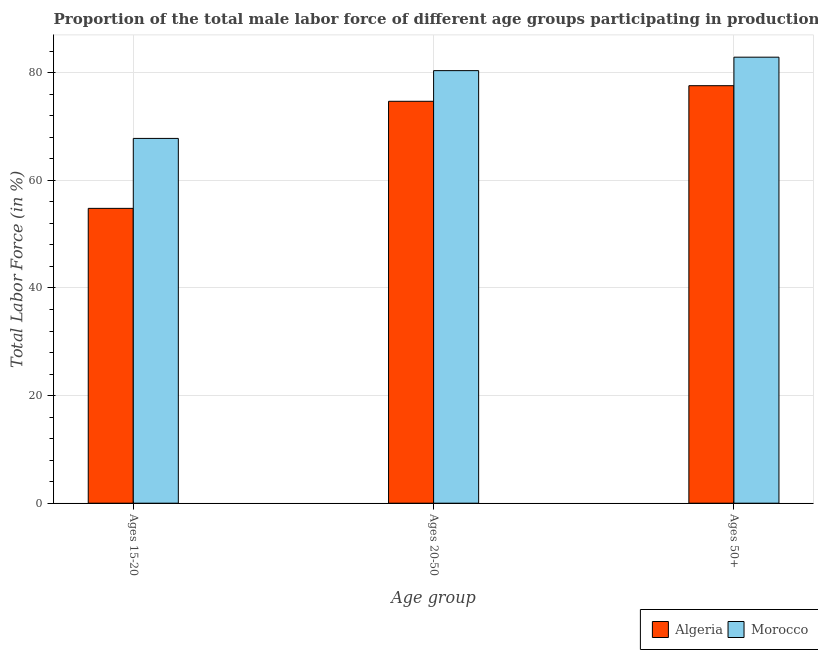How many different coloured bars are there?
Your answer should be very brief. 2. How many bars are there on the 2nd tick from the right?
Ensure brevity in your answer.  2. What is the label of the 2nd group of bars from the left?
Provide a succinct answer. Ages 20-50. What is the percentage of male labor force within the age group 15-20 in Algeria?
Ensure brevity in your answer.  54.8. Across all countries, what is the maximum percentage of male labor force above age 50?
Offer a terse response. 82.9. Across all countries, what is the minimum percentage of male labor force within the age group 20-50?
Make the answer very short. 74.7. In which country was the percentage of male labor force within the age group 20-50 maximum?
Your response must be concise. Morocco. In which country was the percentage of male labor force above age 50 minimum?
Your answer should be very brief. Algeria. What is the total percentage of male labor force above age 50 in the graph?
Make the answer very short. 160.5. What is the difference between the percentage of male labor force within the age group 15-20 in Morocco and that in Algeria?
Provide a succinct answer. 13. What is the difference between the percentage of male labor force within the age group 15-20 in Algeria and the percentage of male labor force above age 50 in Morocco?
Your response must be concise. -28.1. What is the average percentage of male labor force above age 50 per country?
Ensure brevity in your answer.  80.25. What is the difference between the percentage of male labor force within the age group 20-50 and percentage of male labor force above age 50 in Algeria?
Provide a succinct answer. -2.9. In how many countries, is the percentage of male labor force above age 50 greater than 76 %?
Offer a terse response. 2. What is the ratio of the percentage of male labor force above age 50 in Algeria to that in Morocco?
Offer a very short reply. 0.94. Is the difference between the percentage of male labor force within the age group 15-20 in Algeria and Morocco greater than the difference between the percentage of male labor force above age 50 in Algeria and Morocco?
Offer a very short reply. No. What is the difference between the highest and the second highest percentage of male labor force within the age group 20-50?
Your answer should be very brief. 5.7. What is the difference between the highest and the lowest percentage of male labor force within the age group 20-50?
Provide a short and direct response. 5.7. In how many countries, is the percentage of male labor force within the age group 20-50 greater than the average percentage of male labor force within the age group 20-50 taken over all countries?
Give a very brief answer. 1. Is the sum of the percentage of male labor force within the age group 20-50 in Morocco and Algeria greater than the maximum percentage of male labor force within the age group 15-20 across all countries?
Your answer should be compact. Yes. What does the 1st bar from the left in Ages 50+ represents?
Ensure brevity in your answer.  Algeria. What does the 1st bar from the right in Ages 20-50 represents?
Your answer should be compact. Morocco. How many countries are there in the graph?
Keep it short and to the point. 2. What is the difference between two consecutive major ticks on the Y-axis?
Your response must be concise. 20. How are the legend labels stacked?
Your answer should be compact. Horizontal. What is the title of the graph?
Your answer should be compact. Proportion of the total male labor force of different age groups participating in production in 1990. What is the label or title of the X-axis?
Make the answer very short. Age group. What is the Total Labor Force (in %) of Algeria in Ages 15-20?
Offer a terse response. 54.8. What is the Total Labor Force (in %) in Morocco in Ages 15-20?
Offer a terse response. 67.8. What is the Total Labor Force (in %) in Algeria in Ages 20-50?
Provide a short and direct response. 74.7. What is the Total Labor Force (in %) of Morocco in Ages 20-50?
Your answer should be compact. 80.4. What is the Total Labor Force (in %) of Algeria in Ages 50+?
Provide a short and direct response. 77.6. What is the Total Labor Force (in %) in Morocco in Ages 50+?
Your answer should be compact. 82.9. Across all Age group, what is the maximum Total Labor Force (in %) in Algeria?
Keep it short and to the point. 77.6. Across all Age group, what is the maximum Total Labor Force (in %) of Morocco?
Offer a very short reply. 82.9. Across all Age group, what is the minimum Total Labor Force (in %) in Algeria?
Your response must be concise. 54.8. Across all Age group, what is the minimum Total Labor Force (in %) of Morocco?
Your answer should be very brief. 67.8. What is the total Total Labor Force (in %) of Algeria in the graph?
Provide a short and direct response. 207.1. What is the total Total Labor Force (in %) of Morocco in the graph?
Your answer should be compact. 231.1. What is the difference between the Total Labor Force (in %) in Algeria in Ages 15-20 and that in Ages 20-50?
Make the answer very short. -19.9. What is the difference between the Total Labor Force (in %) in Algeria in Ages 15-20 and that in Ages 50+?
Make the answer very short. -22.8. What is the difference between the Total Labor Force (in %) of Morocco in Ages 15-20 and that in Ages 50+?
Offer a very short reply. -15.1. What is the difference between the Total Labor Force (in %) in Algeria in Ages 20-50 and that in Ages 50+?
Your answer should be very brief. -2.9. What is the difference between the Total Labor Force (in %) of Algeria in Ages 15-20 and the Total Labor Force (in %) of Morocco in Ages 20-50?
Make the answer very short. -25.6. What is the difference between the Total Labor Force (in %) in Algeria in Ages 15-20 and the Total Labor Force (in %) in Morocco in Ages 50+?
Provide a short and direct response. -28.1. What is the difference between the Total Labor Force (in %) of Algeria in Ages 20-50 and the Total Labor Force (in %) of Morocco in Ages 50+?
Offer a very short reply. -8.2. What is the average Total Labor Force (in %) in Algeria per Age group?
Ensure brevity in your answer.  69.03. What is the average Total Labor Force (in %) in Morocco per Age group?
Make the answer very short. 77.03. What is the difference between the Total Labor Force (in %) of Algeria and Total Labor Force (in %) of Morocco in Ages 50+?
Provide a short and direct response. -5.3. What is the ratio of the Total Labor Force (in %) of Algeria in Ages 15-20 to that in Ages 20-50?
Provide a succinct answer. 0.73. What is the ratio of the Total Labor Force (in %) of Morocco in Ages 15-20 to that in Ages 20-50?
Your response must be concise. 0.84. What is the ratio of the Total Labor Force (in %) of Algeria in Ages 15-20 to that in Ages 50+?
Ensure brevity in your answer.  0.71. What is the ratio of the Total Labor Force (in %) in Morocco in Ages 15-20 to that in Ages 50+?
Offer a terse response. 0.82. What is the ratio of the Total Labor Force (in %) in Algeria in Ages 20-50 to that in Ages 50+?
Offer a very short reply. 0.96. What is the ratio of the Total Labor Force (in %) of Morocco in Ages 20-50 to that in Ages 50+?
Provide a short and direct response. 0.97. What is the difference between the highest and the second highest Total Labor Force (in %) of Algeria?
Offer a very short reply. 2.9. What is the difference between the highest and the second highest Total Labor Force (in %) in Morocco?
Keep it short and to the point. 2.5. What is the difference between the highest and the lowest Total Labor Force (in %) in Algeria?
Give a very brief answer. 22.8. What is the difference between the highest and the lowest Total Labor Force (in %) in Morocco?
Your response must be concise. 15.1. 